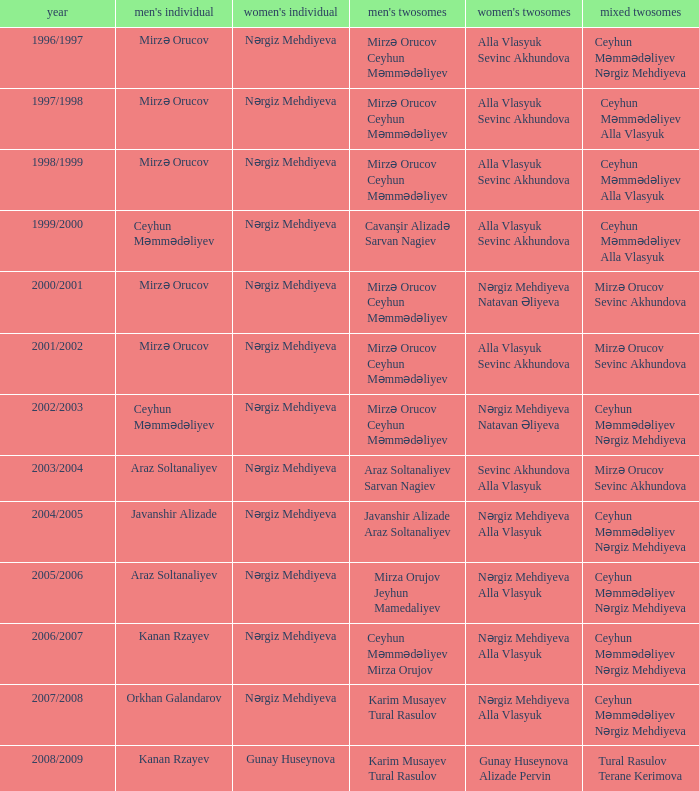What are all values for Womens Doubles in the year 2000/2001? Nərgiz Mehdiyeva Natavan Əliyeva. 